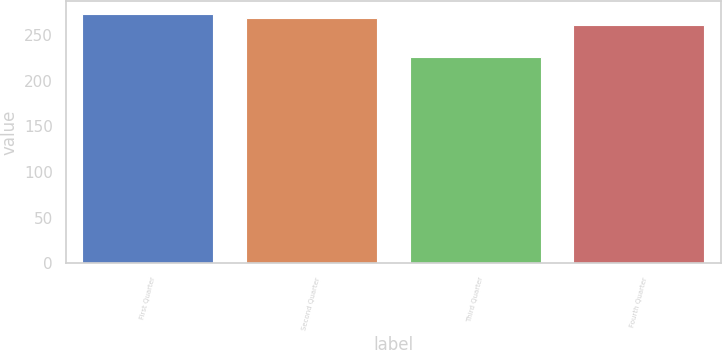<chart> <loc_0><loc_0><loc_500><loc_500><bar_chart><fcel>First Quarter<fcel>Second Quarter<fcel>Third Quarter<fcel>Fourth Quarter<nl><fcel>273.58<fcel>269.22<fcel>226.3<fcel>260.72<nl></chart> 